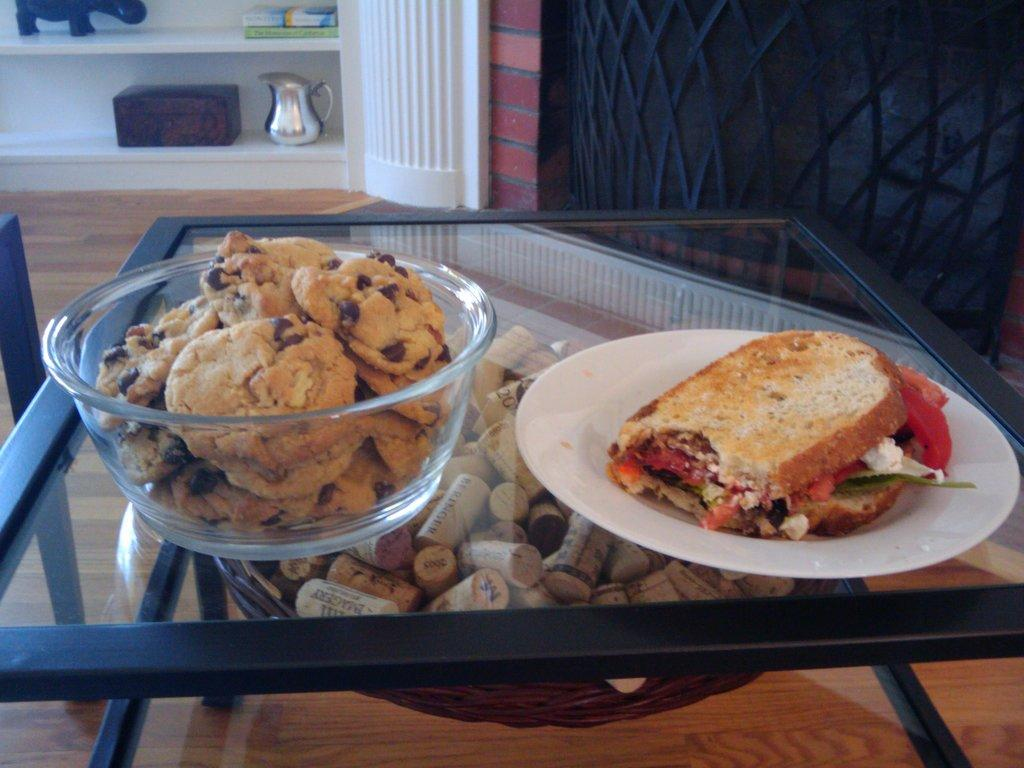What is located in the foreground of the image? There is a table in the foreground of the image. What food items can be seen on the table? Cookies in a bowl and a sandwich on a plate are placed on the table. What objects are visible in the background of the image? In the background, there is a jar, a box, books on a shelf, and a toy on a shelf. What color is the hydrant in the image? There is no hydrant present in the image. What type of pen is used to write on the books in the image? There is no pen visible in the image, and it is not mentioned that the books have been written on. 